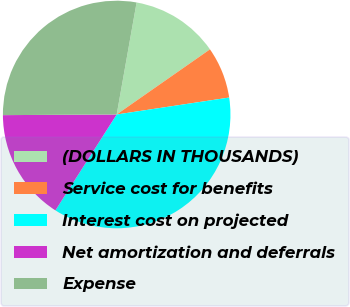<chart> <loc_0><loc_0><loc_500><loc_500><pie_chart><fcel>(DOLLARS IN THOUSANDS)<fcel>Service cost for benefits<fcel>Interest cost on projected<fcel>Net amortization and deferrals<fcel>Expense<nl><fcel>12.5%<fcel>7.32%<fcel>36.43%<fcel>15.86%<fcel>27.89%<nl></chart> 